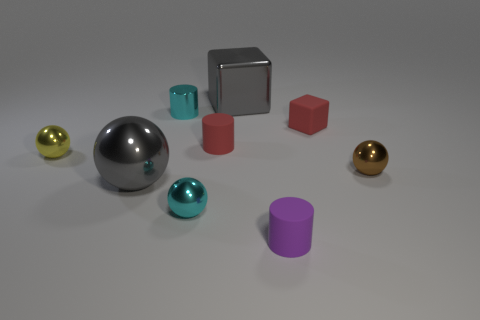Does the shiny block have the same color as the large sphere?
Make the answer very short. Yes. What material is the thing that is the same color as the small block?
Keep it short and to the point. Rubber. How many blue metal balls are there?
Provide a short and direct response. 0. What shape is the shiny thing that is behind the yellow sphere and in front of the shiny block?
Keep it short and to the point. Cylinder. The tiny matte object to the left of the big cube behind the small matte cylinder that is to the right of the gray block is what shape?
Your response must be concise. Cylinder. There is a tiny thing that is in front of the brown metallic thing and behind the small purple thing; what material is it made of?
Ensure brevity in your answer.  Metal. How many matte cylinders are the same size as the red cube?
Offer a terse response. 2. What number of rubber things are red things or cyan cylinders?
Keep it short and to the point. 2. What material is the tiny cyan cylinder?
Ensure brevity in your answer.  Metal. What number of gray things are in front of the small cyan cylinder?
Provide a succinct answer. 1. 